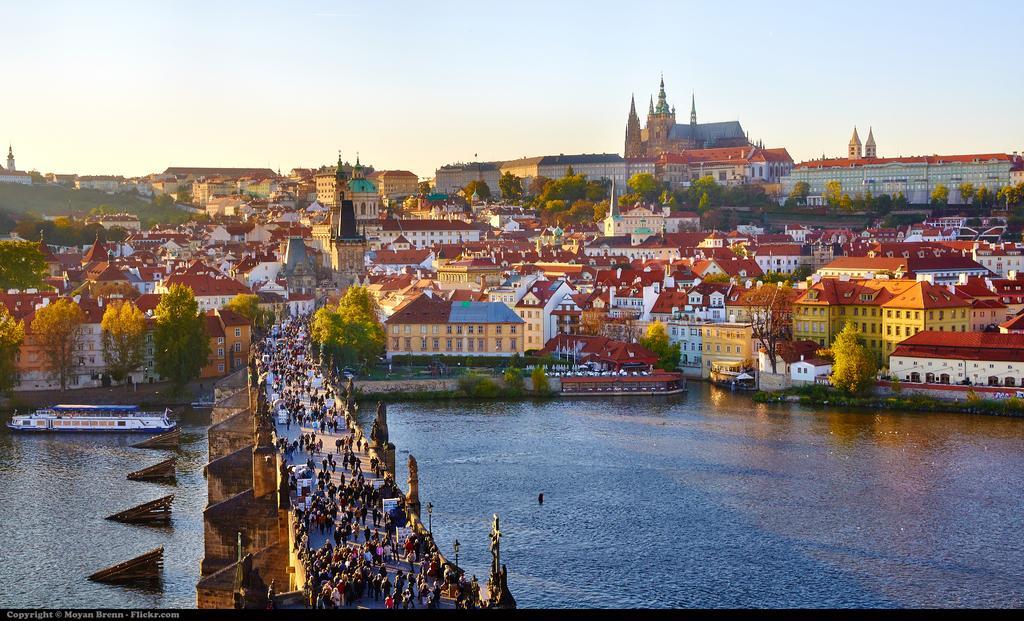Can you describe this image briefly? In the picture there is water, on the water there are ships, there is a bridged, there are many people present on the bridge, there are trees, there are houses, there is a clear sky. 